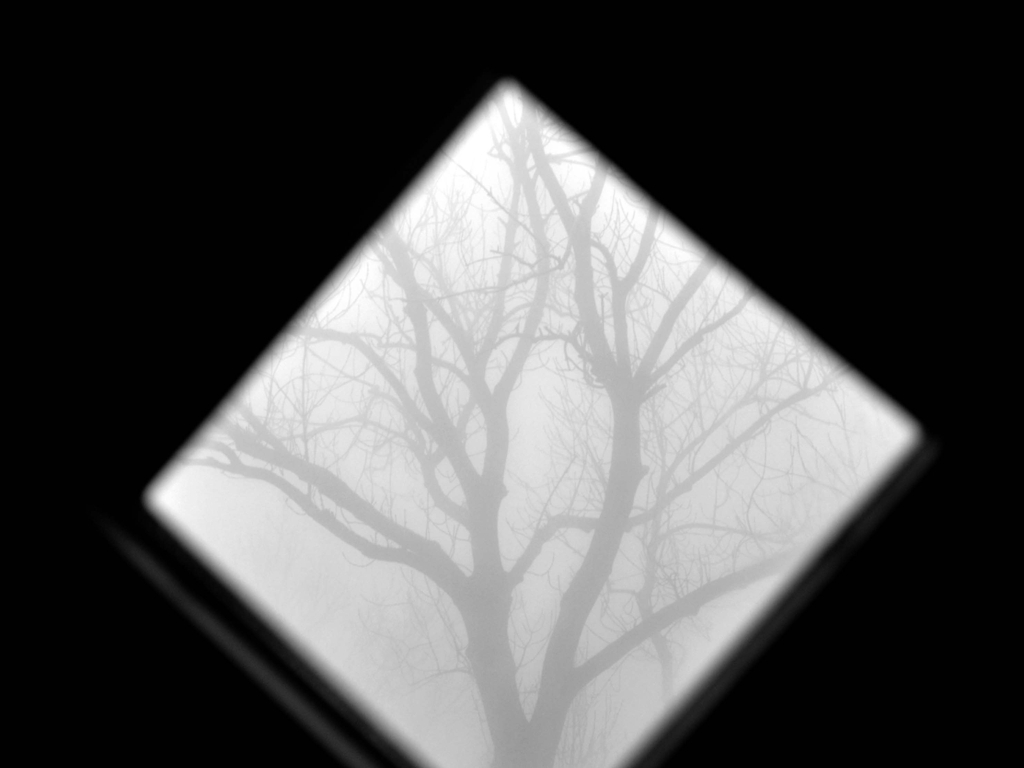Can the weather conditions seen in the image be related to themes of clarity and obscurity in life? Absolutely, the foggy conditions in the image serve as a powerful metaphor for moments in life when our path or decisions are not clear. Just as the fog obscures the landscape, life too can sometimes feel uncertain and indistinct, with choices and consequences hidden in a metaphorical mist. It speaks to the human experience of navigating through unclear circumstances, emphasizing the need for introspection and cautious deliberation in times of uncertainty. 